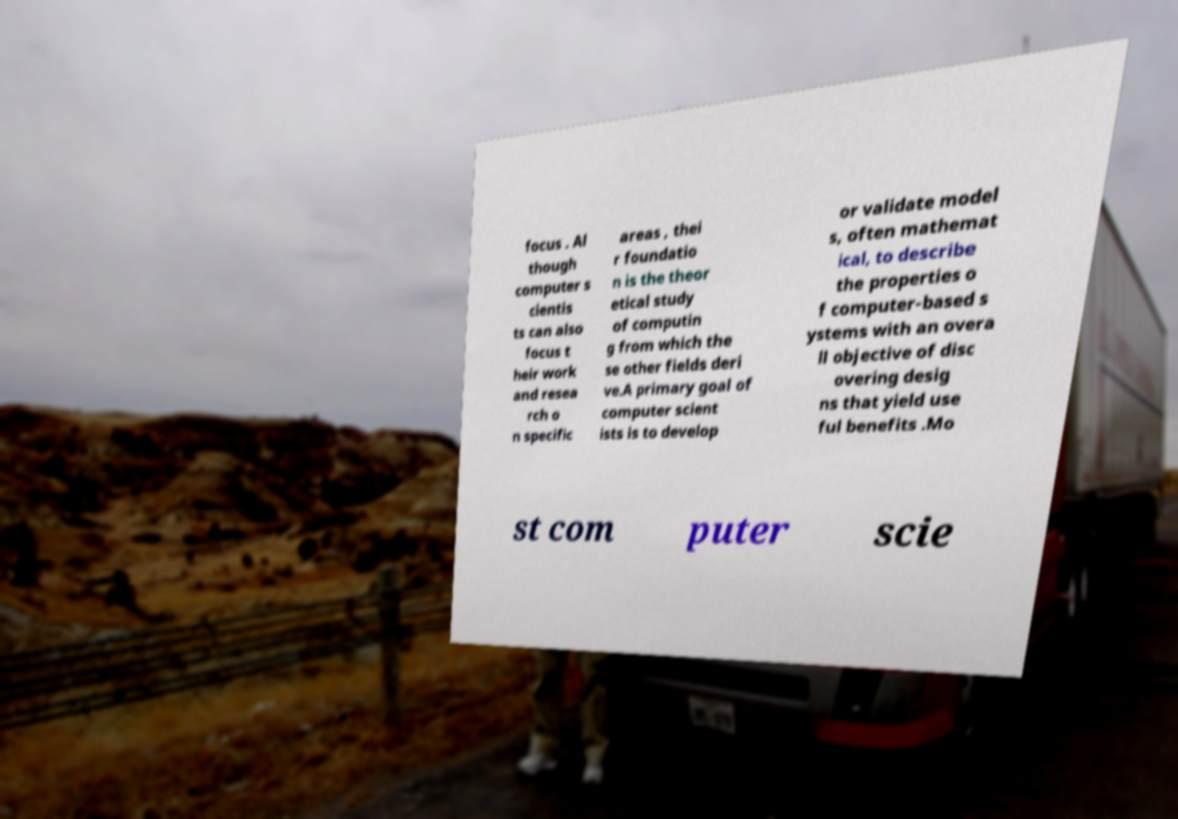Please identify and transcribe the text found in this image. focus . Al though computer s cientis ts can also focus t heir work and resea rch o n specific areas , thei r foundatio n is the theor etical study of computin g from which the se other fields deri ve.A primary goal of computer scient ists is to develop or validate model s, often mathemat ical, to describe the properties o f computer-based s ystems with an overa ll objective of disc overing desig ns that yield use ful benefits .Mo st com puter scie 